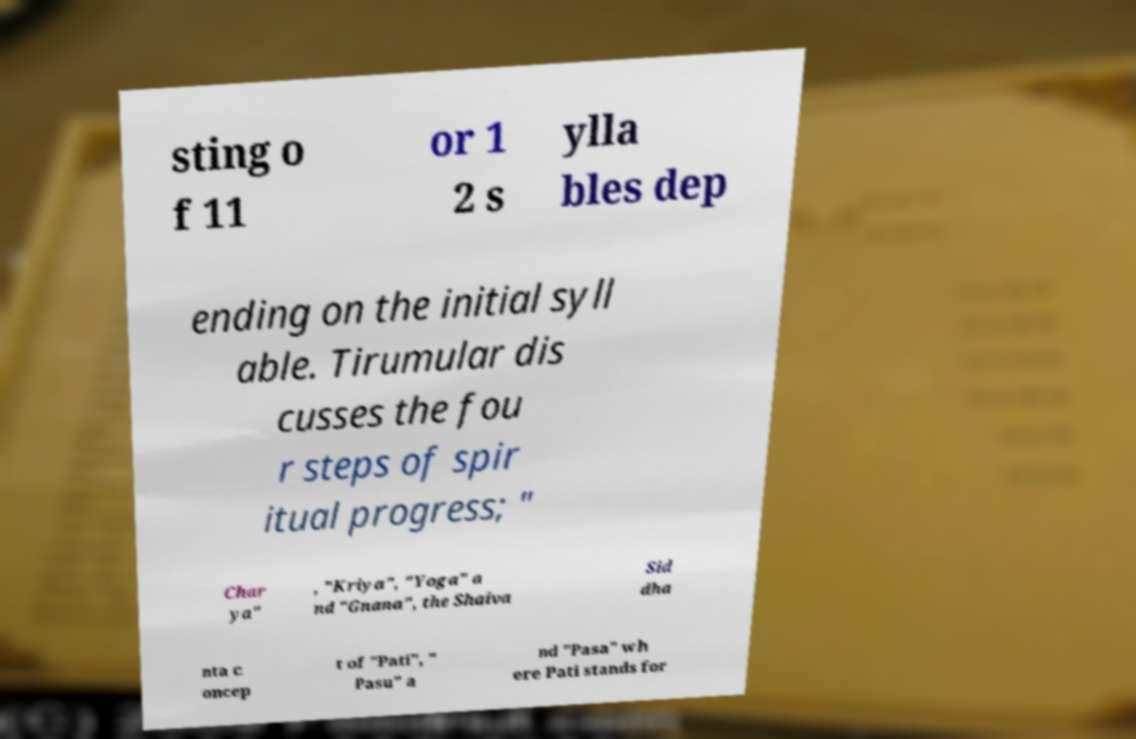Could you extract and type out the text from this image? sting o f 11 or 1 2 s ylla bles dep ending on the initial syll able. Tirumular dis cusses the fou r steps of spir itual progress; " Char ya" , "Kriya", "Yoga" a nd "Gnana", the Shaiva Sid dha nta c oncep t of "Pati", " Pasu" a nd "Pasa" wh ere Pati stands for 